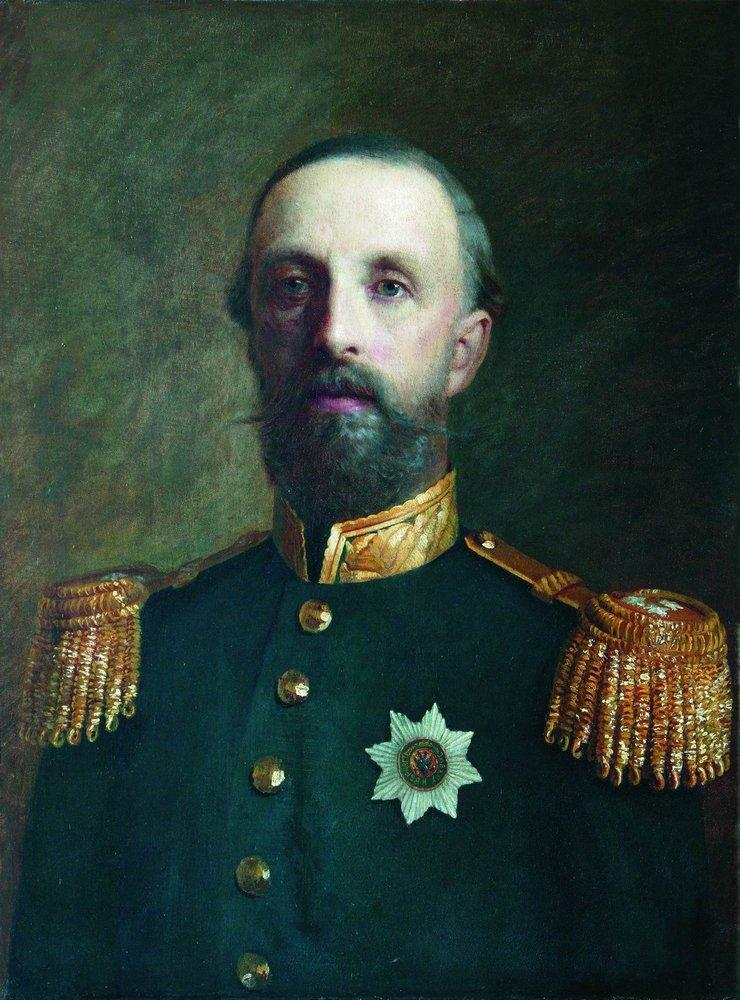What does his facial expression and posture say about his personality or status? His facial expression and posture convey a sense of stern authority and confidence, traits befitting a high-ranking military officer. His upright posture, direct gaze, and composed facial expression suggest a disciplined and determined character, likely respected and admired by his peers. This portrayal aligns with traditional representations of military leaders, emphasizing their leadership qualities and the respect they command. 